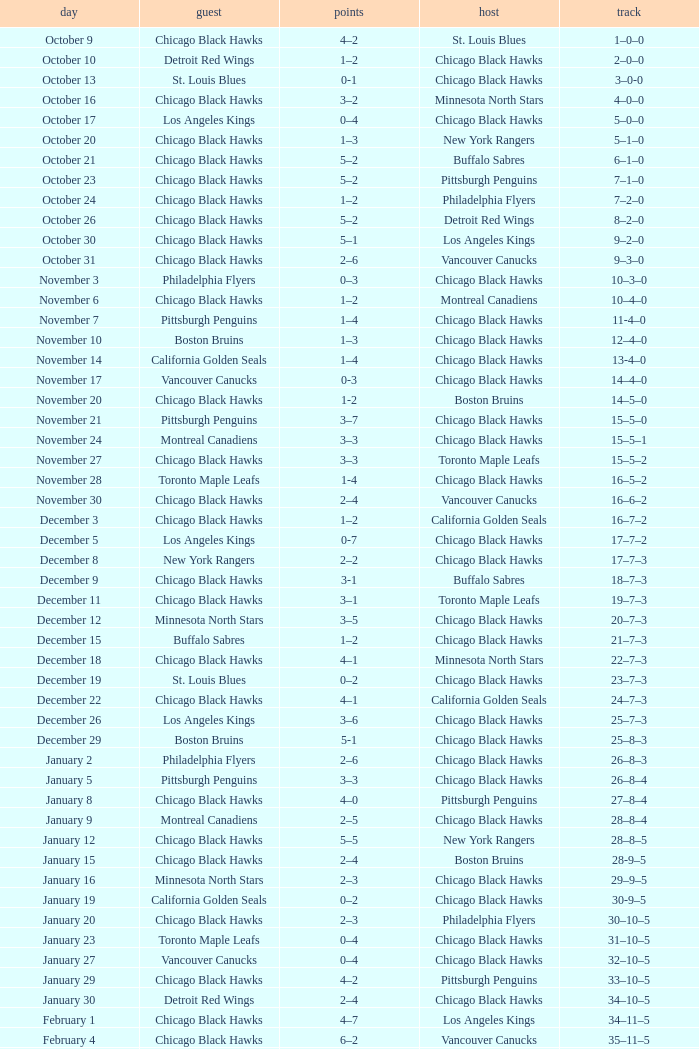What is the february 10th record? 36–13–5. 